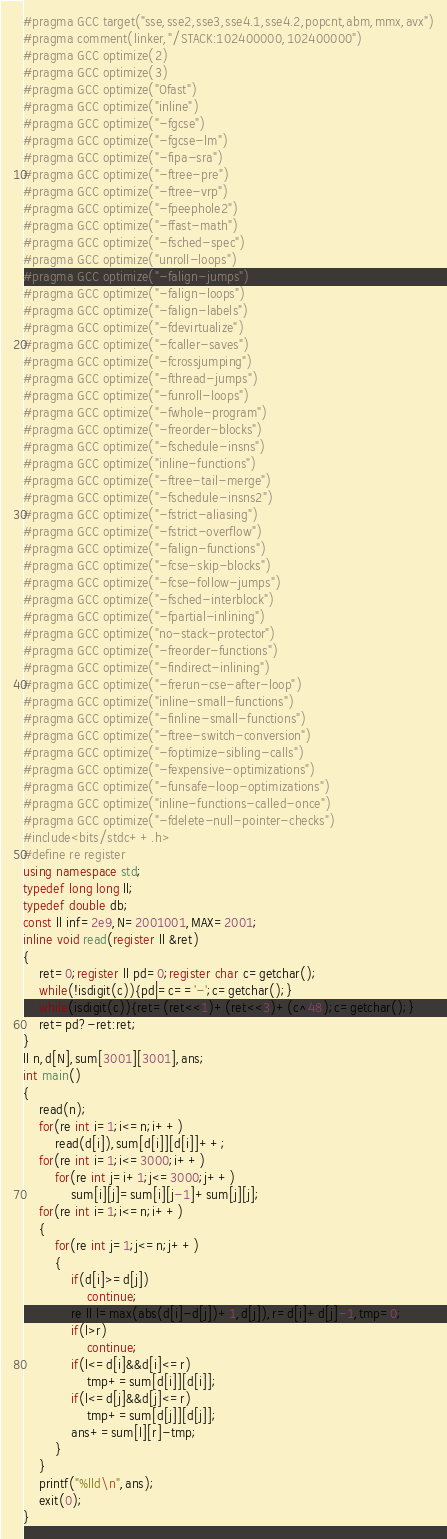Convert code to text. <code><loc_0><loc_0><loc_500><loc_500><_C++_>#pragma GCC target("sse,sse2,sse3,sse4.1,sse4.2,popcnt,abm,mmx,avx")
#pragma comment(linker,"/STACK:102400000,102400000")
#pragma GCC optimize(2)
#pragma GCC optimize(3)
#pragma GCC optimize("Ofast")
#pragma GCC optimize("inline")
#pragma GCC optimize("-fgcse")
#pragma GCC optimize("-fgcse-lm")
#pragma GCC optimize("-fipa-sra")
#pragma GCC optimize("-ftree-pre")
#pragma GCC optimize("-ftree-vrp")
#pragma GCC optimize("-fpeephole2")
#pragma GCC optimize("-ffast-math")
#pragma GCC optimize("-fsched-spec")
#pragma GCC optimize("unroll-loops")
#pragma GCC optimize("-falign-jumps")
#pragma GCC optimize("-falign-loops")
#pragma GCC optimize("-falign-labels")
#pragma GCC optimize("-fdevirtualize")
#pragma GCC optimize("-fcaller-saves")
#pragma GCC optimize("-fcrossjumping")
#pragma GCC optimize("-fthread-jumps")
#pragma GCC optimize("-funroll-loops")
#pragma GCC optimize("-fwhole-program")
#pragma GCC optimize("-freorder-blocks")
#pragma GCC optimize("-fschedule-insns")
#pragma GCC optimize("inline-functions")
#pragma GCC optimize("-ftree-tail-merge")
#pragma GCC optimize("-fschedule-insns2")
#pragma GCC optimize("-fstrict-aliasing")
#pragma GCC optimize("-fstrict-overflow")
#pragma GCC optimize("-falign-functions")
#pragma GCC optimize("-fcse-skip-blocks")
#pragma GCC optimize("-fcse-follow-jumps")
#pragma GCC optimize("-fsched-interblock")
#pragma GCC optimize("-fpartial-inlining")
#pragma GCC optimize("no-stack-protector")
#pragma GCC optimize("-freorder-functions")
#pragma GCC optimize("-findirect-inlining")
#pragma GCC optimize("-frerun-cse-after-loop")
#pragma GCC optimize("inline-small-functions")
#pragma GCC optimize("-finline-small-functions")
#pragma GCC optimize("-ftree-switch-conversion")
#pragma GCC optimize("-foptimize-sibling-calls")
#pragma GCC optimize("-fexpensive-optimizations")
#pragma GCC optimize("-funsafe-loop-optimizations")
#pragma GCC optimize("inline-functions-called-once")
#pragma GCC optimize("-fdelete-null-pointer-checks")
#include<bits/stdc++.h>
#define re register
using namespace std;
typedef long long ll;
typedef double db;
const ll inf=2e9,N=2001001,MAX=2001;
inline void read(register ll &ret)
{
    ret=0;register ll pd=0;register char c=getchar();
    while(!isdigit(c)){pd|=c=='-';c=getchar();}
    while(isdigit(c)){ret=(ret<<1)+(ret<<3)+(c^48);c=getchar();}
    ret=pd?-ret:ret;
}
ll n,d[N],sum[3001][3001],ans;
int main()
{
	read(n);
	for(re int i=1;i<=n;i++)
		read(d[i]),sum[d[i]][d[i]]++;
	for(re int i=1;i<=3000;i++)
		for(re int j=i+1;j<=3000;j++)
			sum[i][j]=sum[i][j-1]+sum[j][j];
	for(re int i=1;i<=n;i++)
	{
		for(re int j=1;j<=n;j++)
		{
			if(d[i]>=d[j])
				continue;
			re ll l=max(abs(d[i]-d[j])+1,d[j]),r=d[i]+d[j]-1,tmp=0;
			if(l>r)
				continue;
			if(l<=d[i]&&d[i]<=r)
				tmp+=sum[d[i]][d[i]];
			if(l<=d[j]&&d[j]<=r)
				tmp+=sum[d[j]][d[j]];
			ans+=sum[l][r]-tmp;
		}
	}
	printf("%lld\n",ans);
	exit(0);
}

</code> 